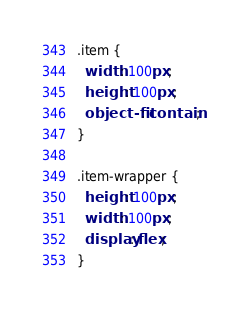Convert code to text. <code><loc_0><loc_0><loc_500><loc_500><_CSS_>.item {
  width: 100px;
  height: 100px;
  object-fit: contain;
}

.item-wrapper {
  height: 100px;
  width: 100px;
  display: flex;
}
</code> 